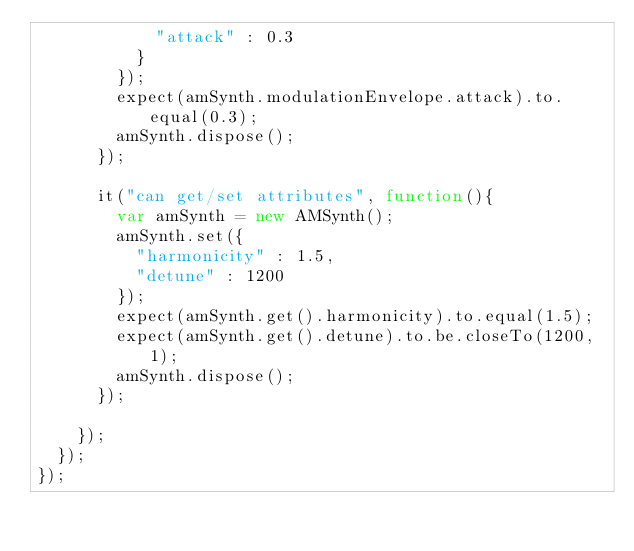Convert code to text. <code><loc_0><loc_0><loc_500><loc_500><_JavaScript_>						"attack" : 0.3
					}
				});
				expect(amSynth.modulationEnvelope.attack).to.equal(0.3);
				amSynth.dispose();
			});

			it("can get/set attributes", function(){
				var amSynth = new AMSynth();
				amSynth.set({
					"harmonicity" : 1.5,
					"detune" : 1200
				});
				expect(amSynth.get().harmonicity).to.equal(1.5);
				expect(amSynth.get().detune).to.be.closeTo(1200, 1);
				amSynth.dispose();
			});

		});
	});
});
</code> 